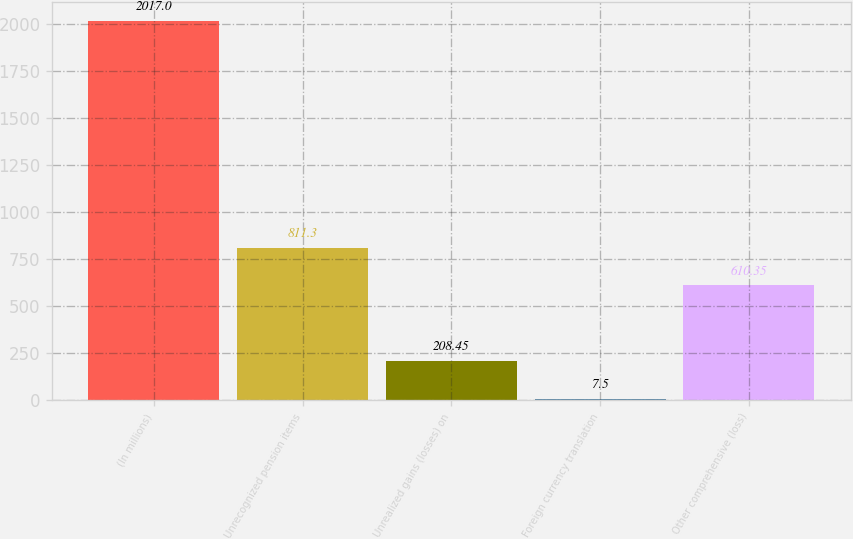<chart> <loc_0><loc_0><loc_500><loc_500><bar_chart><fcel>(In millions)<fcel>Unrecognized pension items<fcel>Unrealized gains (losses) on<fcel>Foreign currency translation<fcel>Other comprehensive (loss)<nl><fcel>2017<fcel>811.3<fcel>208.45<fcel>7.5<fcel>610.35<nl></chart> 